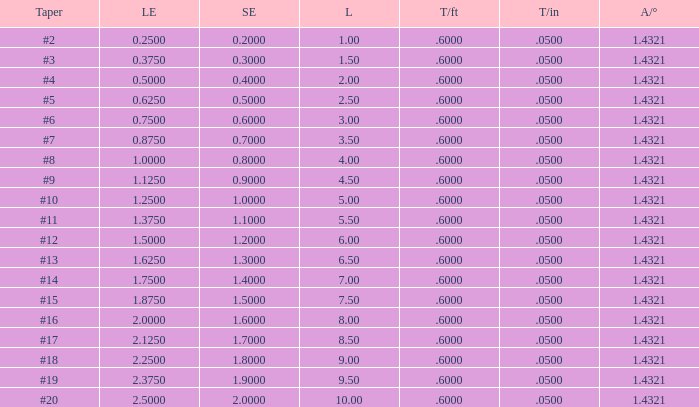Which Angle from center/° has a Taper/ft smaller than 0.6000000000000001? 19.0. 